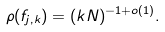Convert formula to latex. <formula><loc_0><loc_0><loc_500><loc_500>\rho ( f _ { j , k } ) = ( k N ) ^ { - 1 + o ( 1 ) } .</formula> 